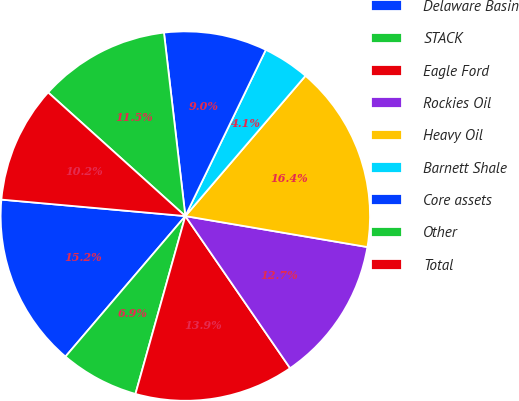<chart> <loc_0><loc_0><loc_500><loc_500><pie_chart><fcel>Delaware Basin<fcel>STACK<fcel>Eagle Ford<fcel>Rockies Oil<fcel>Heavy Oil<fcel>Barnett Shale<fcel>Core assets<fcel>Other<fcel>Total<nl><fcel>15.18%<fcel>6.89%<fcel>13.95%<fcel>12.72%<fcel>16.41%<fcel>4.1%<fcel>9.02%<fcel>11.48%<fcel>10.25%<nl></chart> 